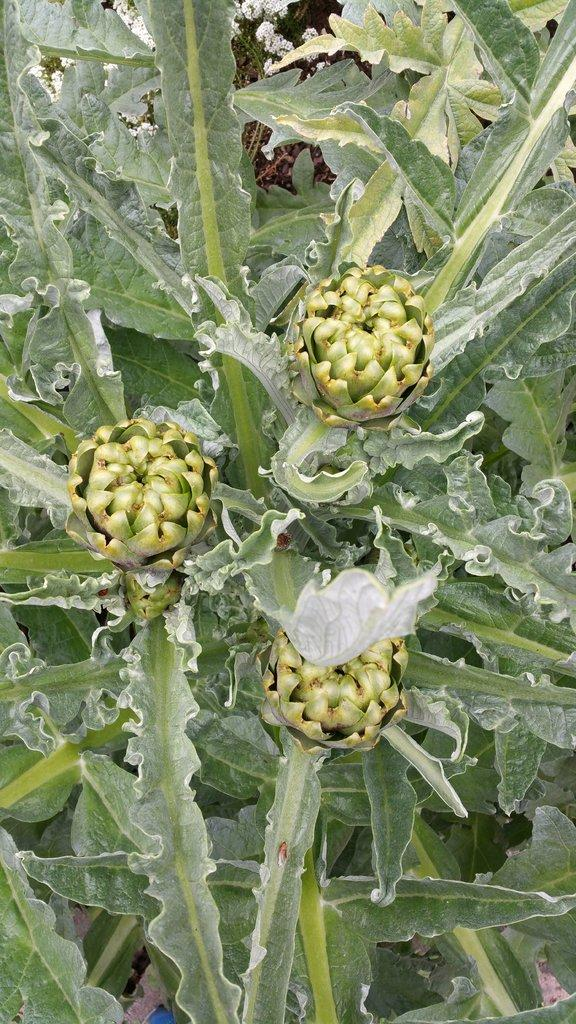What type of vegetation can be seen in the image? There are leaves in the image. What else can be found among the leaves in the image? There are fruits in the image. What type of worm can be seen crawling on the leaves in the image? There are no worms present in the image; it only features leaves and fruits. 